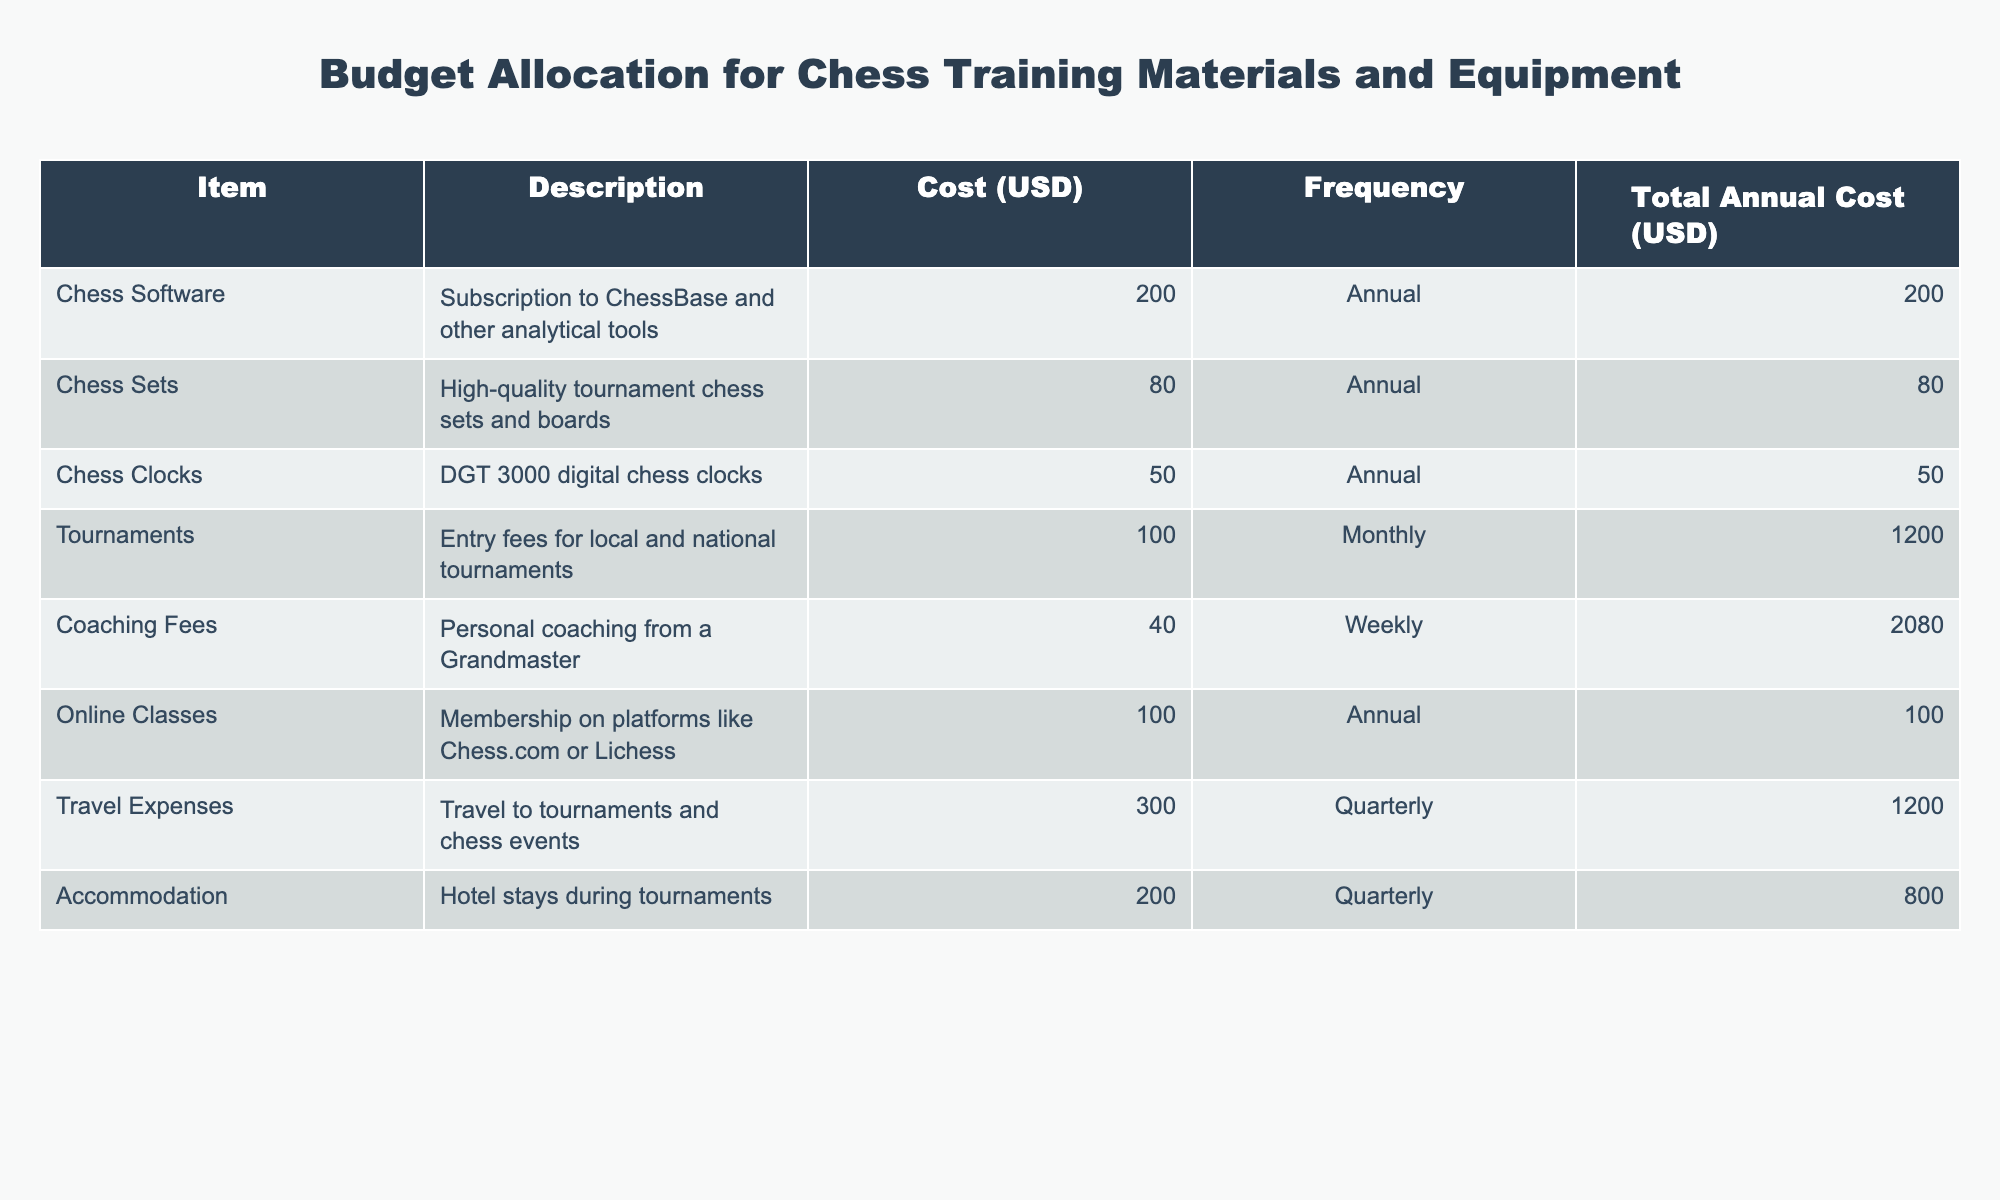What is the total annual cost for coaching fees? The table shows the coaching fees as 40 USD weekly. To find the total annual cost, multiply the weekly cost by the number of weeks in a year (40 * 52 = 2080).
Answer: 2080 How much do you spend on tournaments annually? The entry fee for tournaments is 100 USD monthly. To find the annual cost, multiply the monthly fee by the number of months in a year (100 * 12 = 1200).
Answer: 1200 Which item has the highest total annual cost? Looking at the total annual costs, coaching fees (2080) is the highest compared to other items in the table.
Answer: Coaching Fees Are travel expenses less than the combined costs of chess software and chess sets? The travel expenses total 1200 USD, while chess software is 200 USD and chess sets are 80 USD. Adding these together (200 + 80 = 280), 1200 is greater than 280, thus travel expenses are greater than the combined costs of those two items.
Answer: No What is the total annual cost if we consider all items except tournaments and travel expenses? First, sum up the total annual costs of the remaining items: chess software (200) + chess sets (80) + chess clocks (50) + coaching fees (2080) + online classes (100) + accommodation (800). The total is (200 + 80 + 50 + 2080 + 100 + 800 = 3310).
Answer: 3310 How often do you pay for chess software? The table indicates that chess software is paid for annually.
Answer: Annually Is the total cost for chess sets more than 50% of the coaching fees? The cost for chess sets is 80 USD, while coaching fees total 2080 USD. Calculating 50% of coaching fees gives 1040 USD (2080 * 0.5). Since 80 is much less than 1040, chess sets do not exceed 50% of coaching fees.
Answer: No What is the difference in cost between coaching fees and accommodation? Coaching fees are 2080 USD annually and accommodation costs 800 USD annually. The difference is calculated as (2080 - 800 = 1280).
Answer: 1280 Which two items combined cost the same as the travel expenses? Travel expenses total 1200 USD. Looking at the costs, the sum of chess clocks (50) and online classes (100) is 150, which does not match. However, the entry fee for tournaments (1200) alone equals the travel expenses. Hence, there are no two items that combine to equal travel expenses.
Answer: No 